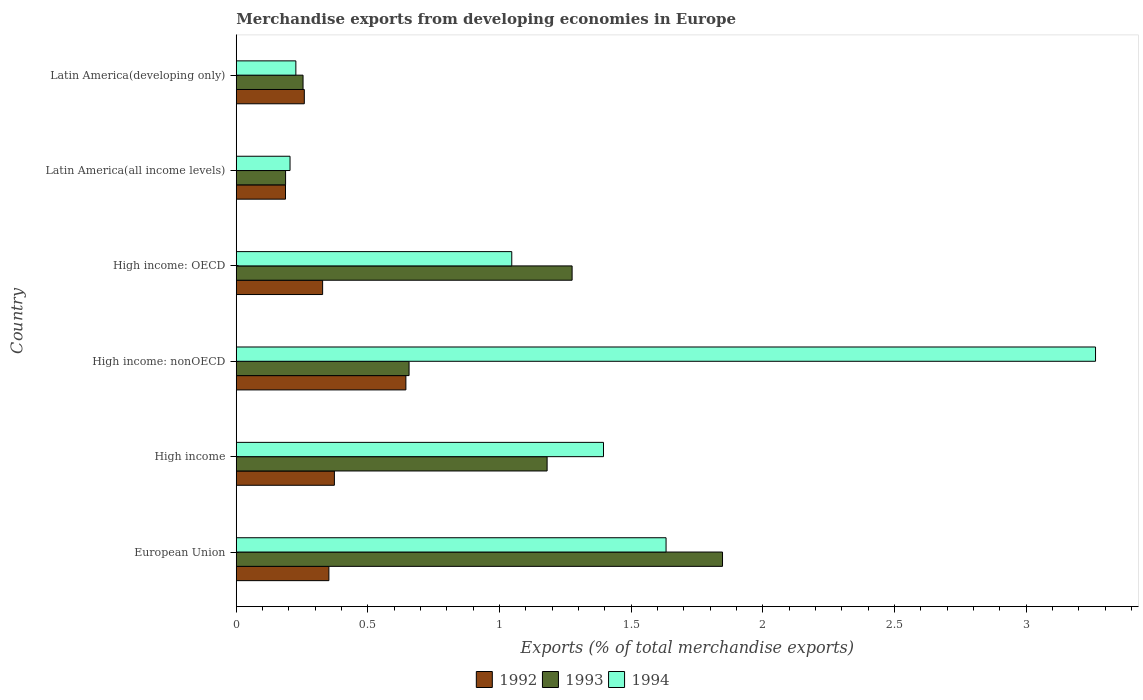How many different coloured bars are there?
Your response must be concise. 3. How many bars are there on the 3rd tick from the top?
Your answer should be very brief. 3. What is the label of the 4th group of bars from the top?
Your answer should be compact. High income: nonOECD. In how many cases, is the number of bars for a given country not equal to the number of legend labels?
Provide a short and direct response. 0. What is the percentage of total merchandise exports in 1992 in Latin America(all income levels)?
Offer a very short reply. 0.19. Across all countries, what is the maximum percentage of total merchandise exports in 1993?
Give a very brief answer. 1.85. Across all countries, what is the minimum percentage of total merchandise exports in 1992?
Make the answer very short. 0.19. In which country was the percentage of total merchandise exports in 1992 minimum?
Provide a short and direct response. Latin America(all income levels). What is the total percentage of total merchandise exports in 1994 in the graph?
Give a very brief answer. 7.77. What is the difference between the percentage of total merchandise exports in 1993 in High income: nonOECD and that in Latin America(developing only)?
Your answer should be very brief. 0.4. What is the difference between the percentage of total merchandise exports in 1994 in High income: OECD and the percentage of total merchandise exports in 1993 in Latin America(all income levels)?
Make the answer very short. 0.86. What is the average percentage of total merchandise exports in 1994 per country?
Provide a short and direct response. 1.29. What is the difference between the percentage of total merchandise exports in 1994 and percentage of total merchandise exports in 1993 in European Union?
Offer a very short reply. -0.21. What is the ratio of the percentage of total merchandise exports in 1994 in European Union to that in Latin America(all income levels)?
Your response must be concise. 7.99. What is the difference between the highest and the second highest percentage of total merchandise exports in 1992?
Offer a very short reply. 0.27. What is the difference between the highest and the lowest percentage of total merchandise exports in 1994?
Make the answer very short. 3.06. In how many countries, is the percentage of total merchandise exports in 1994 greater than the average percentage of total merchandise exports in 1994 taken over all countries?
Keep it short and to the point. 3. Is the sum of the percentage of total merchandise exports in 1994 in High income: OECD and Latin America(all income levels) greater than the maximum percentage of total merchandise exports in 1993 across all countries?
Provide a succinct answer. No. What does the 2nd bar from the top in European Union represents?
Offer a terse response. 1993. What does the 2nd bar from the bottom in High income: OECD represents?
Your answer should be very brief. 1993. Is it the case that in every country, the sum of the percentage of total merchandise exports in 1994 and percentage of total merchandise exports in 1992 is greater than the percentage of total merchandise exports in 1993?
Provide a succinct answer. Yes. How many bars are there?
Make the answer very short. 18. How many countries are there in the graph?
Give a very brief answer. 6. Are the values on the major ticks of X-axis written in scientific E-notation?
Keep it short and to the point. No. Does the graph contain any zero values?
Ensure brevity in your answer.  No. Where does the legend appear in the graph?
Make the answer very short. Bottom center. How are the legend labels stacked?
Provide a short and direct response. Horizontal. What is the title of the graph?
Your response must be concise. Merchandise exports from developing economies in Europe. What is the label or title of the X-axis?
Your response must be concise. Exports (% of total merchandise exports). What is the label or title of the Y-axis?
Offer a terse response. Country. What is the Exports (% of total merchandise exports) of 1992 in European Union?
Your answer should be very brief. 0.35. What is the Exports (% of total merchandise exports) of 1993 in European Union?
Provide a short and direct response. 1.85. What is the Exports (% of total merchandise exports) of 1994 in European Union?
Your answer should be compact. 1.63. What is the Exports (% of total merchandise exports) of 1992 in High income?
Your response must be concise. 0.37. What is the Exports (% of total merchandise exports) in 1993 in High income?
Provide a short and direct response. 1.18. What is the Exports (% of total merchandise exports) of 1994 in High income?
Ensure brevity in your answer.  1.39. What is the Exports (% of total merchandise exports) of 1992 in High income: nonOECD?
Provide a succinct answer. 0.64. What is the Exports (% of total merchandise exports) of 1993 in High income: nonOECD?
Give a very brief answer. 0.66. What is the Exports (% of total merchandise exports) in 1994 in High income: nonOECD?
Your response must be concise. 3.26. What is the Exports (% of total merchandise exports) in 1992 in High income: OECD?
Your response must be concise. 0.33. What is the Exports (% of total merchandise exports) of 1993 in High income: OECD?
Ensure brevity in your answer.  1.28. What is the Exports (% of total merchandise exports) in 1994 in High income: OECD?
Give a very brief answer. 1.05. What is the Exports (% of total merchandise exports) of 1992 in Latin America(all income levels)?
Your answer should be compact. 0.19. What is the Exports (% of total merchandise exports) in 1993 in Latin America(all income levels)?
Offer a terse response. 0.19. What is the Exports (% of total merchandise exports) in 1994 in Latin America(all income levels)?
Your response must be concise. 0.2. What is the Exports (% of total merchandise exports) of 1992 in Latin America(developing only)?
Your answer should be very brief. 0.26. What is the Exports (% of total merchandise exports) of 1993 in Latin America(developing only)?
Your response must be concise. 0.25. What is the Exports (% of total merchandise exports) in 1994 in Latin America(developing only)?
Provide a succinct answer. 0.23. Across all countries, what is the maximum Exports (% of total merchandise exports) of 1992?
Your response must be concise. 0.64. Across all countries, what is the maximum Exports (% of total merchandise exports) in 1993?
Ensure brevity in your answer.  1.85. Across all countries, what is the maximum Exports (% of total merchandise exports) of 1994?
Offer a terse response. 3.26. Across all countries, what is the minimum Exports (% of total merchandise exports) in 1992?
Provide a short and direct response. 0.19. Across all countries, what is the minimum Exports (% of total merchandise exports) in 1993?
Ensure brevity in your answer.  0.19. Across all countries, what is the minimum Exports (% of total merchandise exports) in 1994?
Offer a very short reply. 0.2. What is the total Exports (% of total merchandise exports) of 1992 in the graph?
Provide a short and direct response. 2.14. What is the total Exports (% of total merchandise exports) of 1993 in the graph?
Offer a very short reply. 5.4. What is the total Exports (% of total merchandise exports) of 1994 in the graph?
Provide a short and direct response. 7.77. What is the difference between the Exports (% of total merchandise exports) in 1992 in European Union and that in High income?
Provide a short and direct response. -0.02. What is the difference between the Exports (% of total merchandise exports) in 1993 in European Union and that in High income?
Your response must be concise. 0.67. What is the difference between the Exports (% of total merchandise exports) in 1994 in European Union and that in High income?
Ensure brevity in your answer.  0.24. What is the difference between the Exports (% of total merchandise exports) in 1992 in European Union and that in High income: nonOECD?
Provide a succinct answer. -0.29. What is the difference between the Exports (% of total merchandise exports) of 1993 in European Union and that in High income: nonOECD?
Offer a very short reply. 1.19. What is the difference between the Exports (% of total merchandise exports) in 1994 in European Union and that in High income: nonOECD?
Offer a very short reply. -1.63. What is the difference between the Exports (% of total merchandise exports) of 1992 in European Union and that in High income: OECD?
Provide a succinct answer. 0.02. What is the difference between the Exports (% of total merchandise exports) in 1993 in European Union and that in High income: OECD?
Make the answer very short. 0.57. What is the difference between the Exports (% of total merchandise exports) in 1994 in European Union and that in High income: OECD?
Provide a short and direct response. 0.59. What is the difference between the Exports (% of total merchandise exports) in 1992 in European Union and that in Latin America(all income levels)?
Your answer should be compact. 0.16. What is the difference between the Exports (% of total merchandise exports) of 1993 in European Union and that in Latin America(all income levels)?
Keep it short and to the point. 1.66. What is the difference between the Exports (% of total merchandise exports) of 1994 in European Union and that in Latin America(all income levels)?
Offer a terse response. 1.43. What is the difference between the Exports (% of total merchandise exports) of 1992 in European Union and that in Latin America(developing only)?
Give a very brief answer. 0.09. What is the difference between the Exports (% of total merchandise exports) in 1993 in European Union and that in Latin America(developing only)?
Provide a short and direct response. 1.59. What is the difference between the Exports (% of total merchandise exports) of 1994 in European Union and that in Latin America(developing only)?
Your answer should be very brief. 1.41. What is the difference between the Exports (% of total merchandise exports) of 1992 in High income and that in High income: nonOECD?
Ensure brevity in your answer.  -0.27. What is the difference between the Exports (% of total merchandise exports) of 1993 in High income and that in High income: nonOECD?
Make the answer very short. 0.52. What is the difference between the Exports (% of total merchandise exports) in 1994 in High income and that in High income: nonOECD?
Keep it short and to the point. -1.87. What is the difference between the Exports (% of total merchandise exports) in 1992 in High income and that in High income: OECD?
Offer a very short reply. 0.04. What is the difference between the Exports (% of total merchandise exports) in 1993 in High income and that in High income: OECD?
Make the answer very short. -0.09. What is the difference between the Exports (% of total merchandise exports) of 1994 in High income and that in High income: OECD?
Provide a succinct answer. 0.35. What is the difference between the Exports (% of total merchandise exports) in 1992 in High income and that in Latin America(all income levels)?
Provide a succinct answer. 0.19. What is the difference between the Exports (% of total merchandise exports) of 1993 in High income and that in Latin America(all income levels)?
Your response must be concise. 0.99. What is the difference between the Exports (% of total merchandise exports) of 1994 in High income and that in Latin America(all income levels)?
Offer a very short reply. 1.19. What is the difference between the Exports (% of total merchandise exports) in 1992 in High income and that in Latin America(developing only)?
Provide a short and direct response. 0.11. What is the difference between the Exports (% of total merchandise exports) of 1993 in High income and that in Latin America(developing only)?
Provide a short and direct response. 0.93. What is the difference between the Exports (% of total merchandise exports) in 1994 in High income and that in Latin America(developing only)?
Your answer should be very brief. 1.17. What is the difference between the Exports (% of total merchandise exports) in 1992 in High income: nonOECD and that in High income: OECD?
Provide a short and direct response. 0.32. What is the difference between the Exports (% of total merchandise exports) in 1993 in High income: nonOECD and that in High income: OECD?
Offer a terse response. -0.62. What is the difference between the Exports (% of total merchandise exports) in 1994 in High income: nonOECD and that in High income: OECD?
Offer a terse response. 2.22. What is the difference between the Exports (% of total merchandise exports) in 1992 in High income: nonOECD and that in Latin America(all income levels)?
Ensure brevity in your answer.  0.46. What is the difference between the Exports (% of total merchandise exports) of 1993 in High income: nonOECD and that in Latin America(all income levels)?
Provide a succinct answer. 0.47. What is the difference between the Exports (% of total merchandise exports) in 1994 in High income: nonOECD and that in Latin America(all income levels)?
Provide a succinct answer. 3.06. What is the difference between the Exports (% of total merchandise exports) in 1992 in High income: nonOECD and that in Latin America(developing only)?
Offer a terse response. 0.39. What is the difference between the Exports (% of total merchandise exports) of 1993 in High income: nonOECD and that in Latin America(developing only)?
Offer a very short reply. 0.4. What is the difference between the Exports (% of total merchandise exports) in 1994 in High income: nonOECD and that in Latin America(developing only)?
Ensure brevity in your answer.  3.04. What is the difference between the Exports (% of total merchandise exports) of 1992 in High income: OECD and that in Latin America(all income levels)?
Ensure brevity in your answer.  0.14. What is the difference between the Exports (% of total merchandise exports) of 1993 in High income: OECD and that in Latin America(all income levels)?
Offer a very short reply. 1.09. What is the difference between the Exports (% of total merchandise exports) of 1994 in High income: OECD and that in Latin America(all income levels)?
Make the answer very short. 0.84. What is the difference between the Exports (% of total merchandise exports) of 1992 in High income: OECD and that in Latin America(developing only)?
Give a very brief answer. 0.07. What is the difference between the Exports (% of total merchandise exports) of 1993 in High income: OECD and that in Latin America(developing only)?
Your answer should be very brief. 1.02. What is the difference between the Exports (% of total merchandise exports) in 1994 in High income: OECD and that in Latin America(developing only)?
Provide a short and direct response. 0.82. What is the difference between the Exports (% of total merchandise exports) of 1992 in Latin America(all income levels) and that in Latin America(developing only)?
Make the answer very short. -0.07. What is the difference between the Exports (% of total merchandise exports) of 1993 in Latin America(all income levels) and that in Latin America(developing only)?
Your answer should be compact. -0.07. What is the difference between the Exports (% of total merchandise exports) in 1994 in Latin America(all income levels) and that in Latin America(developing only)?
Your response must be concise. -0.02. What is the difference between the Exports (% of total merchandise exports) in 1992 in European Union and the Exports (% of total merchandise exports) in 1993 in High income?
Provide a short and direct response. -0.83. What is the difference between the Exports (% of total merchandise exports) of 1992 in European Union and the Exports (% of total merchandise exports) of 1994 in High income?
Make the answer very short. -1.04. What is the difference between the Exports (% of total merchandise exports) in 1993 in European Union and the Exports (% of total merchandise exports) in 1994 in High income?
Your answer should be very brief. 0.45. What is the difference between the Exports (% of total merchandise exports) of 1992 in European Union and the Exports (% of total merchandise exports) of 1993 in High income: nonOECD?
Offer a very short reply. -0.3. What is the difference between the Exports (% of total merchandise exports) in 1992 in European Union and the Exports (% of total merchandise exports) in 1994 in High income: nonOECD?
Ensure brevity in your answer.  -2.91. What is the difference between the Exports (% of total merchandise exports) in 1993 in European Union and the Exports (% of total merchandise exports) in 1994 in High income: nonOECD?
Offer a very short reply. -1.42. What is the difference between the Exports (% of total merchandise exports) in 1992 in European Union and the Exports (% of total merchandise exports) in 1993 in High income: OECD?
Provide a succinct answer. -0.92. What is the difference between the Exports (% of total merchandise exports) of 1992 in European Union and the Exports (% of total merchandise exports) of 1994 in High income: OECD?
Your answer should be compact. -0.69. What is the difference between the Exports (% of total merchandise exports) in 1993 in European Union and the Exports (% of total merchandise exports) in 1994 in High income: OECD?
Provide a succinct answer. 0.8. What is the difference between the Exports (% of total merchandise exports) of 1992 in European Union and the Exports (% of total merchandise exports) of 1993 in Latin America(all income levels)?
Offer a very short reply. 0.16. What is the difference between the Exports (% of total merchandise exports) in 1992 in European Union and the Exports (% of total merchandise exports) in 1994 in Latin America(all income levels)?
Offer a terse response. 0.15. What is the difference between the Exports (% of total merchandise exports) of 1993 in European Union and the Exports (% of total merchandise exports) of 1994 in Latin America(all income levels)?
Your response must be concise. 1.64. What is the difference between the Exports (% of total merchandise exports) in 1992 in European Union and the Exports (% of total merchandise exports) in 1993 in Latin America(developing only)?
Make the answer very short. 0.1. What is the difference between the Exports (% of total merchandise exports) of 1992 in European Union and the Exports (% of total merchandise exports) of 1994 in Latin America(developing only)?
Your answer should be very brief. 0.13. What is the difference between the Exports (% of total merchandise exports) of 1993 in European Union and the Exports (% of total merchandise exports) of 1994 in Latin America(developing only)?
Ensure brevity in your answer.  1.62. What is the difference between the Exports (% of total merchandise exports) of 1992 in High income and the Exports (% of total merchandise exports) of 1993 in High income: nonOECD?
Your response must be concise. -0.28. What is the difference between the Exports (% of total merchandise exports) of 1992 in High income and the Exports (% of total merchandise exports) of 1994 in High income: nonOECD?
Offer a terse response. -2.89. What is the difference between the Exports (% of total merchandise exports) in 1993 in High income and the Exports (% of total merchandise exports) in 1994 in High income: nonOECD?
Give a very brief answer. -2.08. What is the difference between the Exports (% of total merchandise exports) in 1992 in High income and the Exports (% of total merchandise exports) in 1993 in High income: OECD?
Keep it short and to the point. -0.9. What is the difference between the Exports (% of total merchandise exports) in 1992 in High income and the Exports (% of total merchandise exports) in 1994 in High income: OECD?
Provide a succinct answer. -0.67. What is the difference between the Exports (% of total merchandise exports) of 1993 in High income and the Exports (% of total merchandise exports) of 1994 in High income: OECD?
Your response must be concise. 0.13. What is the difference between the Exports (% of total merchandise exports) in 1992 in High income and the Exports (% of total merchandise exports) in 1993 in Latin America(all income levels)?
Offer a very short reply. 0.19. What is the difference between the Exports (% of total merchandise exports) in 1992 in High income and the Exports (% of total merchandise exports) in 1994 in Latin America(all income levels)?
Make the answer very short. 0.17. What is the difference between the Exports (% of total merchandise exports) in 1993 in High income and the Exports (% of total merchandise exports) in 1994 in Latin America(all income levels)?
Give a very brief answer. 0.98. What is the difference between the Exports (% of total merchandise exports) in 1992 in High income and the Exports (% of total merchandise exports) in 1993 in Latin America(developing only)?
Offer a terse response. 0.12. What is the difference between the Exports (% of total merchandise exports) of 1992 in High income and the Exports (% of total merchandise exports) of 1994 in Latin America(developing only)?
Offer a very short reply. 0.15. What is the difference between the Exports (% of total merchandise exports) in 1993 in High income and the Exports (% of total merchandise exports) in 1994 in Latin America(developing only)?
Your answer should be compact. 0.95. What is the difference between the Exports (% of total merchandise exports) of 1992 in High income: nonOECD and the Exports (% of total merchandise exports) of 1993 in High income: OECD?
Keep it short and to the point. -0.63. What is the difference between the Exports (% of total merchandise exports) of 1992 in High income: nonOECD and the Exports (% of total merchandise exports) of 1994 in High income: OECD?
Your answer should be compact. -0.4. What is the difference between the Exports (% of total merchandise exports) in 1993 in High income: nonOECD and the Exports (% of total merchandise exports) in 1994 in High income: OECD?
Give a very brief answer. -0.39. What is the difference between the Exports (% of total merchandise exports) in 1992 in High income: nonOECD and the Exports (% of total merchandise exports) in 1993 in Latin America(all income levels)?
Provide a short and direct response. 0.46. What is the difference between the Exports (% of total merchandise exports) of 1992 in High income: nonOECD and the Exports (% of total merchandise exports) of 1994 in Latin America(all income levels)?
Your answer should be very brief. 0.44. What is the difference between the Exports (% of total merchandise exports) of 1993 in High income: nonOECD and the Exports (% of total merchandise exports) of 1994 in Latin America(all income levels)?
Keep it short and to the point. 0.45. What is the difference between the Exports (% of total merchandise exports) of 1992 in High income: nonOECD and the Exports (% of total merchandise exports) of 1993 in Latin America(developing only)?
Provide a succinct answer. 0.39. What is the difference between the Exports (% of total merchandise exports) in 1992 in High income: nonOECD and the Exports (% of total merchandise exports) in 1994 in Latin America(developing only)?
Your response must be concise. 0.42. What is the difference between the Exports (% of total merchandise exports) in 1993 in High income: nonOECD and the Exports (% of total merchandise exports) in 1994 in Latin America(developing only)?
Offer a very short reply. 0.43. What is the difference between the Exports (% of total merchandise exports) in 1992 in High income: OECD and the Exports (% of total merchandise exports) in 1993 in Latin America(all income levels)?
Keep it short and to the point. 0.14. What is the difference between the Exports (% of total merchandise exports) of 1992 in High income: OECD and the Exports (% of total merchandise exports) of 1994 in Latin America(all income levels)?
Your response must be concise. 0.12. What is the difference between the Exports (% of total merchandise exports) of 1993 in High income: OECD and the Exports (% of total merchandise exports) of 1994 in Latin America(all income levels)?
Ensure brevity in your answer.  1.07. What is the difference between the Exports (% of total merchandise exports) in 1992 in High income: OECD and the Exports (% of total merchandise exports) in 1993 in Latin America(developing only)?
Your answer should be very brief. 0.07. What is the difference between the Exports (% of total merchandise exports) in 1992 in High income: OECD and the Exports (% of total merchandise exports) in 1994 in Latin America(developing only)?
Provide a succinct answer. 0.1. What is the difference between the Exports (% of total merchandise exports) in 1993 in High income: OECD and the Exports (% of total merchandise exports) in 1994 in Latin America(developing only)?
Provide a short and direct response. 1.05. What is the difference between the Exports (% of total merchandise exports) in 1992 in Latin America(all income levels) and the Exports (% of total merchandise exports) in 1993 in Latin America(developing only)?
Provide a succinct answer. -0.07. What is the difference between the Exports (% of total merchandise exports) of 1992 in Latin America(all income levels) and the Exports (% of total merchandise exports) of 1994 in Latin America(developing only)?
Offer a terse response. -0.04. What is the difference between the Exports (% of total merchandise exports) of 1993 in Latin America(all income levels) and the Exports (% of total merchandise exports) of 1994 in Latin America(developing only)?
Make the answer very short. -0.04. What is the average Exports (% of total merchandise exports) of 1992 per country?
Give a very brief answer. 0.36. What is the average Exports (% of total merchandise exports) of 1993 per country?
Give a very brief answer. 0.9. What is the average Exports (% of total merchandise exports) in 1994 per country?
Your response must be concise. 1.29. What is the difference between the Exports (% of total merchandise exports) in 1992 and Exports (% of total merchandise exports) in 1993 in European Union?
Offer a very short reply. -1.49. What is the difference between the Exports (% of total merchandise exports) of 1992 and Exports (% of total merchandise exports) of 1994 in European Union?
Provide a succinct answer. -1.28. What is the difference between the Exports (% of total merchandise exports) of 1993 and Exports (% of total merchandise exports) of 1994 in European Union?
Offer a terse response. 0.21. What is the difference between the Exports (% of total merchandise exports) of 1992 and Exports (% of total merchandise exports) of 1993 in High income?
Your answer should be compact. -0.81. What is the difference between the Exports (% of total merchandise exports) of 1992 and Exports (% of total merchandise exports) of 1994 in High income?
Your answer should be compact. -1.02. What is the difference between the Exports (% of total merchandise exports) of 1993 and Exports (% of total merchandise exports) of 1994 in High income?
Offer a very short reply. -0.21. What is the difference between the Exports (% of total merchandise exports) in 1992 and Exports (% of total merchandise exports) in 1993 in High income: nonOECD?
Offer a terse response. -0.01. What is the difference between the Exports (% of total merchandise exports) in 1992 and Exports (% of total merchandise exports) in 1994 in High income: nonOECD?
Keep it short and to the point. -2.62. What is the difference between the Exports (% of total merchandise exports) in 1993 and Exports (% of total merchandise exports) in 1994 in High income: nonOECD?
Provide a short and direct response. -2.61. What is the difference between the Exports (% of total merchandise exports) of 1992 and Exports (% of total merchandise exports) of 1993 in High income: OECD?
Provide a short and direct response. -0.95. What is the difference between the Exports (% of total merchandise exports) of 1992 and Exports (% of total merchandise exports) of 1994 in High income: OECD?
Offer a very short reply. -0.72. What is the difference between the Exports (% of total merchandise exports) in 1993 and Exports (% of total merchandise exports) in 1994 in High income: OECD?
Offer a terse response. 0.23. What is the difference between the Exports (% of total merchandise exports) of 1992 and Exports (% of total merchandise exports) of 1993 in Latin America(all income levels)?
Offer a very short reply. -0. What is the difference between the Exports (% of total merchandise exports) in 1992 and Exports (% of total merchandise exports) in 1994 in Latin America(all income levels)?
Offer a very short reply. -0.02. What is the difference between the Exports (% of total merchandise exports) of 1993 and Exports (% of total merchandise exports) of 1994 in Latin America(all income levels)?
Provide a succinct answer. -0.02. What is the difference between the Exports (% of total merchandise exports) of 1992 and Exports (% of total merchandise exports) of 1993 in Latin America(developing only)?
Ensure brevity in your answer.  0. What is the difference between the Exports (% of total merchandise exports) in 1992 and Exports (% of total merchandise exports) in 1994 in Latin America(developing only)?
Make the answer very short. 0.03. What is the difference between the Exports (% of total merchandise exports) in 1993 and Exports (% of total merchandise exports) in 1994 in Latin America(developing only)?
Offer a terse response. 0.03. What is the ratio of the Exports (% of total merchandise exports) of 1992 in European Union to that in High income?
Make the answer very short. 0.94. What is the ratio of the Exports (% of total merchandise exports) in 1993 in European Union to that in High income?
Ensure brevity in your answer.  1.56. What is the ratio of the Exports (% of total merchandise exports) in 1994 in European Union to that in High income?
Offer a terse response. 1.17. What is the ratio of the Exports (% of total merchandise exports) of 1992 in European Union to that in High income: nonOECD?
Your answer should be compact. 0.55. What is the ratio of the Exports (% of total merchandise exports) in 1993 in European Union to that in High income: nonOECD?
Offer a terse response. 2.81. What is the ratio of the Exports (% of total merchandise exports) in 1994 in European Union to that in High income: nonOECD?
Keep it short and to the point. 0.5. What is the ratio of the Exports (% of total merchandise exports) in 1992 in European Union to that in High income: OECD?
Offer a terse response. 1.07. What is the ratio of the Exports (% of total merchandise exports) in 1993 in European Union to that in High income: OECD?
Offer a terse response. 1.45. What is the ratio of the Exports (% of total merchandise exports) in 1994 in European Union to that in High income: OECD?
Your answer should be compact. 1.56. What is the ratio of the Exports (% of total merchandise exports) in 1992 in European Union to that in Latin America(all income levels)?
Provide a succinct answer. 1.88. What is the ratio of the Exports (% of total merchandise exports) in 1993 in European Union to that in Latin America(all income levels)?
Your answer should be compact. 9.86. What is the ratio of the Exports (% of total merchandise exports) of 1994 in European Union to that in Latin America(all income levels)?
Keep it short and to the point. 7.99. What is the ratio of the Exports (% of total merchandise exports) in 1992 in European Union to that in Latin America(developing only)?
Make the answer very short. 1.36. What is the ratio of the Exports (% of total merchandise exports) in 1993 in European Union to that in Latin America(developing only)?
Provide a short and direct response. 7.28. What is the ratio of the Exports (% of total merchandise exports) of 1994 in European Union to that in Latin America(developing only)?
Offer a terse response. 7.21. What is the ratio of the Exports (% of total merchandise exports) in 1992 in High income to that in High income: nonOECD?
Give a very brief answer. 0.58. What is the ratio of the Exports (% of total merchandise exports) of 1993 in High income to that in High income: nonOECD?
Offer a very short reply. 1.8. What is the ratio of the Exports (% of total merchandise exports) in 1994 in High income to that in High income: nonOECD?
Your answer should be compact. 0.43. What is the ratio of the Exports (% of total merchandise exports) in 1992 in High income to that in High income: OECD?
Offer a very short reply. 1.14. What is the ratio of the Exports (% of total merchandise exports) in 1993 in High income to that in High income: OECD?
Make the answer very short. 0.93. What is the ratio of the Exports (% of total merchandise exports) of 1994 in High income to that in High income: OECD?
Offer a very short reply. 1.33. What is the ratio of the Exports (% of total merchandise exports) in 1992 in High income to that in Latin America(all income levels)?
Offer a very short reply. 1.99. What is the ratio of the Exports (% of total merchandise exports) of 1993 in High income to that in Latin America(all income levels)?
Provide a succinct answer. 6.3. What is the ratio of the Exports (% of total merchandise exports) in 1994 in High income to that in Latin America(all income levels)?
Offer a very short reply. 6.83. What is the ratio of the Exports (% of total merchandise exports) of 1992 in High income to that in Latin America(developing only)?
Ensure brevity in your answer.  1.44. What is the ratio of the Exports (% of total merchandise exports) of 1993 in High income to that in Latin America(developing only)?
Give a very brief answer. 4.65. What is the ratio of the Exports (% of total merchandise exports) of 1994 in High income to that in Latin America(developing only)?
Provide a succinct answer. 6.16. What is the ratio of the Exports (% of total merchandise exports) of 1992 in High income: nonOECD to that in High income: OECD?
Ensure brevity in your answer.  1.96. What is the ratio of the Exports (% of total merchandise exports) of 1993 in High income: nonOECD to that in High income: OECD?
Ensure brevity in your answer.  0.51. What is the ratio of the Exports (% of total merchandise exports) of 1994 in High income: nonOECD to that in High income: OECD?
Ensure brevity in your answer.  3.12. What is the ratio of the Exports (% of total merchandise exports) of 1992 in High income: nonOECD to that in Latin America(all income levels)?
Ensure brevity in your answer.  3.44. What is the ratio of the Exports (% of total merchandise exports) in 1993 in High income: nonOECD to that in Latin America(all income levels)?
Ensure brevity in your answer.  3.5. What is the ratio of the Exports (% of total merchandise exports) of 1994 in High income: nonOECD to that in Latin America(all income levels)?
Ensure brevity in your answer.  15.98. What is the ratio of the Exports (% of total merchandise exports) of 1992 in High income: nonOECD to that in Latin America(developing only)?
Provide a succinct answer. 2.49. What is the ratio of the Exports (% of total merchandise exports) in 1993 in High income: nonOECD to that in Latin America(developing only)?
Offer a terse response. 2.59. What is the ratio of the Exports (% of total merchandise exports) in 1994 in High income: nonOECD to that in Latin America(developing only)?
Offer a very short reply. 14.42. What is the ratio of the Exports (% of total merchandise exports) in 1992 in High income: OECD to that in Latin America(all income levels)?
Your answer should be very brief. 1.75. What is the ratio of the Exports (% of total merchandise exports) of 1993 in High income: OECD to that in Latin America(all income levels)?
Offer a very short reply. 6.81. What is the ratio of the Exports (% of total merchandise exports) of 1994 in High income: OECD to that in Latin America(all income levels)?
Provide a short and direct response. 5.12. What is the ratio of the Exports (% of total merchandise exports) of 1992 in High income: OECD to that in Latin America(developing only)?
Offer a terse response. 1.27. What is the ratio of the Exports (% of total merchandise exports) of 1993 in High income: OECD to that in Latin America(developing only)?
Ensure brevity in your answer.  5.03. What is the ratio of the Exports (% of total merchandise exports) in 1994 in High income: OECD to that in Latin America(developing only)?
Provide a succinct answer. 4.62. What is the ratio of the Exports (% of total merchandise exports) of 1992 in Latin America(all income levels) to that in Latin America(developing only)?
Provide a short and direct response. 0.72. What is the ratio of the Exports (% of total merchandise exports) of 1993 in Latin America(all income levels) to that in Latin America(developing only)?
Keep it short and to the point. 0.74. What is the ratio of the Exports (% of total merchandise exports) in 1994 in Latin America(all income levels) to that in Latin America(developing only)?
Provide a succinct answer. 0.9. What is the difference between the highest and the second highest Exports (% of total merchandise exports) of 1992?
Your response must be concise. 0.27. What is the difference between the highest and the second highest Exports (% of total merchandise exports) of 1993?
Your response must be concise. 0.57. What is the difference between the highest and the second highest Exports (% of total merchandise exports) in 1994?
Provide a succinct answer. 1.63. What is the difference between the highest and the lowest Exports (% of total merchandise exports) of 1992?
Make the answer very short. 0.46. What is the difference between the highest and the lowest Exports (% of total merchandise exports) in 1993?
Your answer should be compact. 1.66. What is the difference between the highest and the lowest Exports (% of total merchandise exports) in 1994?
Give a very brief answer. 3.06. 